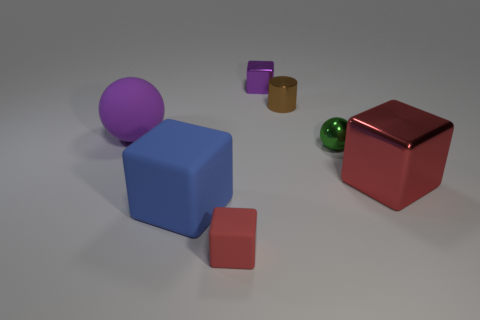Is there any other thing that has the same size as the red shiny cube?
Provide a short and direct response. Yes. The red shiny cube has what size?
Ensure brevity in your answer.  Large. How many tiny objects are either metallic cubes or green metallic objects?
Your answer should be compact. 2. Does the purple sphere have the same size as the metallic thing that is behind the brown shiny object?
Your answer should be compact. No. Is there anything else that has the same shape as the large metal thing?
Your answer should be compact. Yes. How many small green metallic things are there?
Your answer should be very brief. 1. How many purple things are either shiny cylinders or big matte balls?
Provide a short and direct response. 1. Is the block right of the brown metallic cylinder made of the same material as the blue cube?
Ensure brevity in your answer.  No. How many other things are there of the same material as the blue cube?
Offer a very short reply. 2. What is the tiny red block made of?
Offer a terse response. Rubber. 